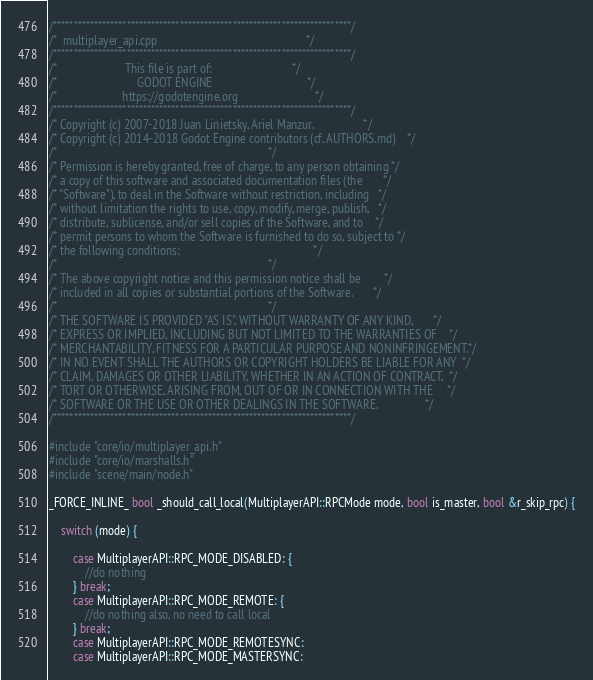Convert code to text. <code><loc_0><loc_0><loc_500><loc_500><_C++_>/*************************************************************************/
/*  multiplayer_api.cpp                                                  */
/*************************************************************************/
/*                       This file is part of:                           */
/*                           GODOT ENGINE                                */
/*                      https://godotengine.org                          */
/*************************************************************************/
/* Copyright (c) 2007-2018 Juan Linietsky, Ariel Manzur.                 */
/* Copyright (c) 2014-2018 Godot Engine contributors (cf. AUTHORS.md)    */
/*                                                                       */
/* Permission is hereby granted, free of charge, to any person obtaining */
/* a copy of this software and associated documentation files (the       */
/* "Software"), to deal in the Software without restriction, including   */
/* without limitation the rights to use, copy, modify, merge, publish,   */
/* distribute, sublicense, and/or sell copies of the Software, and to    */
/* permit persons to whom the Software is furnished to do so, subject to */
/* the following conditions:                                             */
/*                                                                       */
/* The above copyright notice and this permission notice shall be        */
/* included in all copies or substantial portions of the Software.       */
/*                                                                       */
/* THE SOFTWARE IS PROVIDED "AS IS", WITHOUT WARRANTY OF ANY KIND,       */
/* EXPRESS OR IMPLIED, INCLUDING BUT NOT LIMITED TO THE WARRANTIES OF    */
/* MERCHANTABILITY, FITNESS FOR A PARTICULAR PURPOSE AND NONINFRINGEMENT.*/
/* IN NO EVENT SHALL THE AUTHORS OR COPYRIGHT HOLDERS BE LIABLE FOR ANY  */
/* CLAIM, DAMAGES OR OTHER LIABILITY, WHETHER IN AN ACTION OF CONTRACT,  */
/* TORT OR OTHERWISE, ARISING FROM, OUT OF OR IN CONNECTION WITH THE     */
/* SOFTWARE OR THE USE OR OTHER DEALINGS IN THE SOFTWARE.                */
/*************************************************************************/

#include "core/io/multiplayer_api.h"
#include "core/io/marshalls.h"
#include "scene/main/node.h"

_FORCE_INLINE_ bool _should_call_local(MultiplayerAPI::RPCMode mode, bool is_master, bool &r_skip_rpc) {

	switch (mode) {

		case MultiplayerAPI::RPC_MODE_DISABLED: {
			//do nothing
		} break;
		case MultiplayerAPI::RPC_MODE_REMOTE: {
			//do nothing also, no need to call local
		} break;
		case MultiplayerAPI::RPC_MODE_REMOTESYNC:
		case MultiplayerAPI::RPC_MODE_MASTERSYNC:</code> 